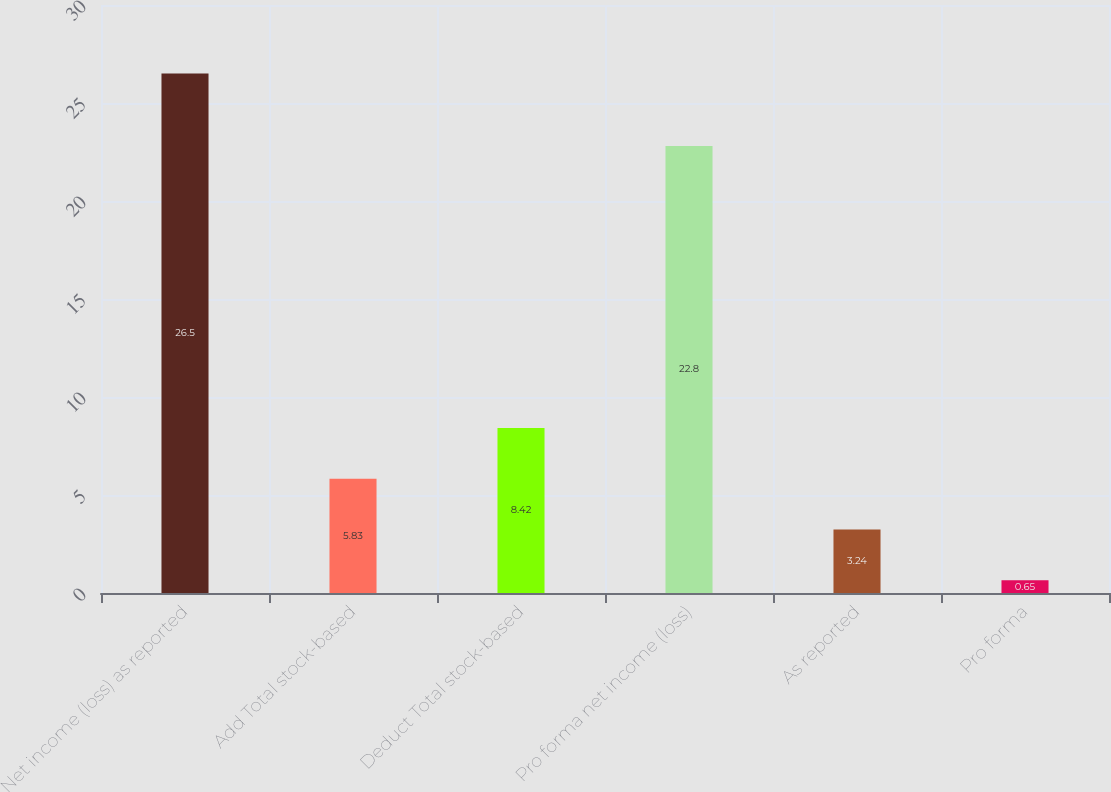<chart> <loc_0><loc_0><loc_500><loc_500><bar_chart><fcel>Net income (loss) as reported<fcel>Add Total stock-based<fcel>Deduct Total stock-based<fcel>Pro forma net income (loss)<fcel>As reported<fcel>Pro forma<nl><fcel>26.5<fcel>5.83<fcel>8.42<fcel>22.8<fcel>3.24<fcel>0.65<nl></chart> 